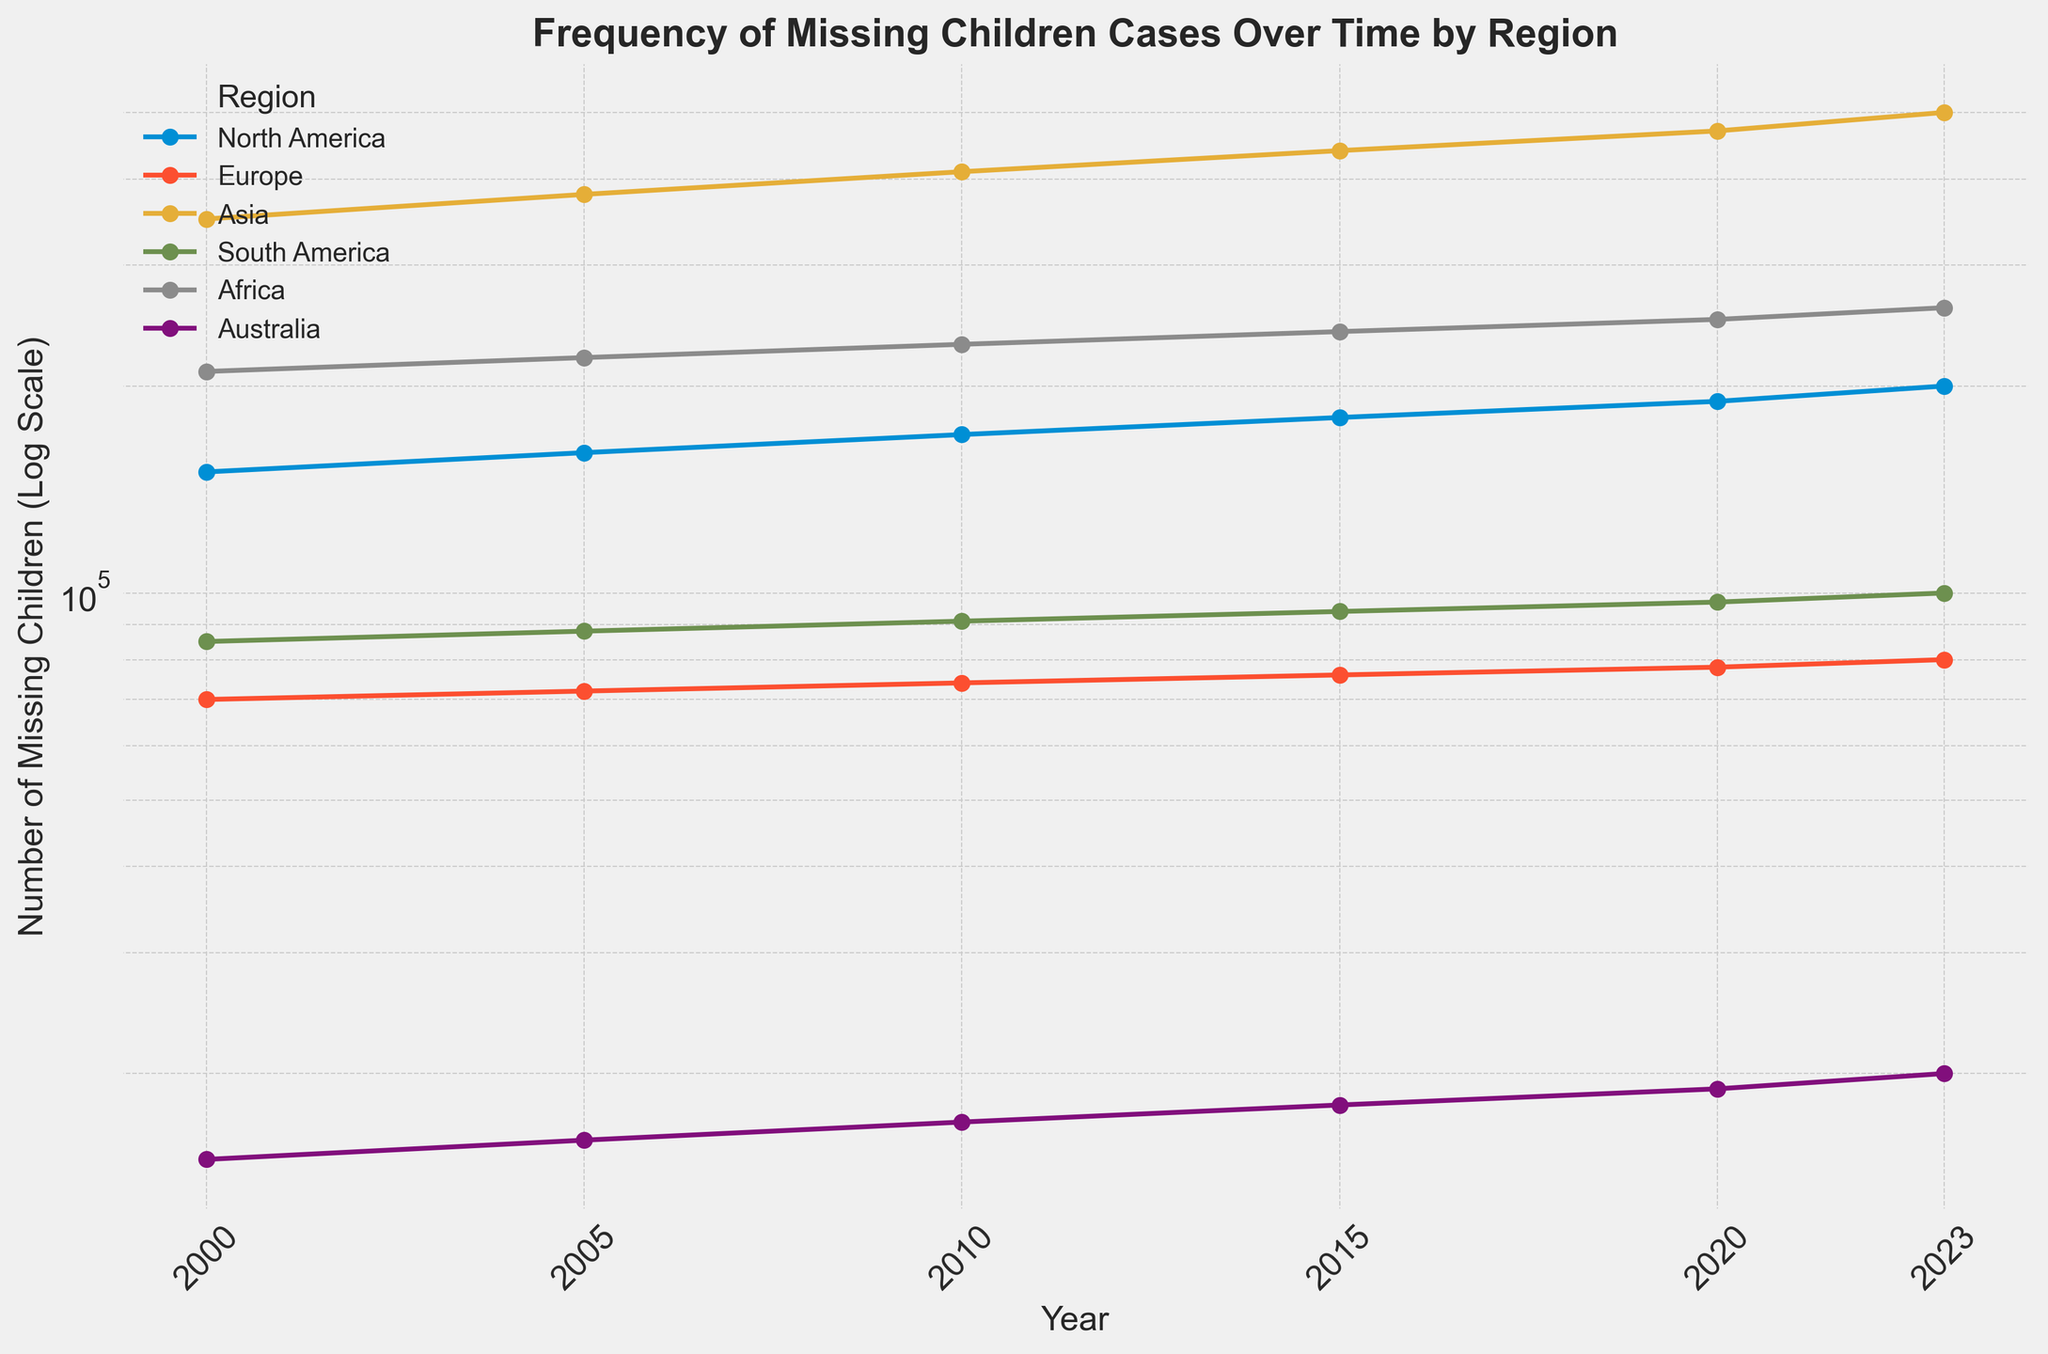What's the region with the highest number of missing children cases in 2023? Looking at the figure, the line representing the number of missing children in Asia is the highest in 2023.
Answer: Asia Which region has the least number of missing children cases consistently across the years? Observing the figure, the line for Australia is consistently the lowest in all the years from 2000 to 2023.
Answer: Australia How has the number of missing children in North America changed from 2000 to 2020? The figure shows that the number of missing children in North America increased from 150,000 in 2000 to 190,000 in 2020.
Answer: Increased In which year did Asia see the largest jump in the number of missing children cases? By examining the figure, Asia shows a significant increase in the number of missing children between 2005 and 2010.
Answer: 2005-2010 What is the approximate ratio of missing children cases in Asia compared to Europe in 2023? In 2023, the number of missing children in Asia is about 500,000, whereas in Europe it's 80,000. The ratio is approximately 500,000 / 80,000 which simplifies to 6.25.
Answer: 6.25 Which regions saw an increase in the number of missing children cases every recorded year (2000, 2005, 2010, 2015, 2020, 2023)? Reviewing the figure, regions such as North America, Asia, and Africa show a consistent increase in missing children cases each time recorded.
Answer: North America, Asia, Africa By how much did the number of missing children in South America increase from 2000 to 2023? The figure indicates an increase from 85,000 in 2000 to 100,000 in 2023, calculated as 100,000 - 85,000, which results in an increase of 15,000.
Answer: 15,000 What trend can be observed in Europe from 2000 to 2023 regarding the number of missing children? The figure shows a slight upward trend in the number of missing children in Europe, rising from 70,000 in 2000 to 80,000 in 2023.
Answer: Slight increase 